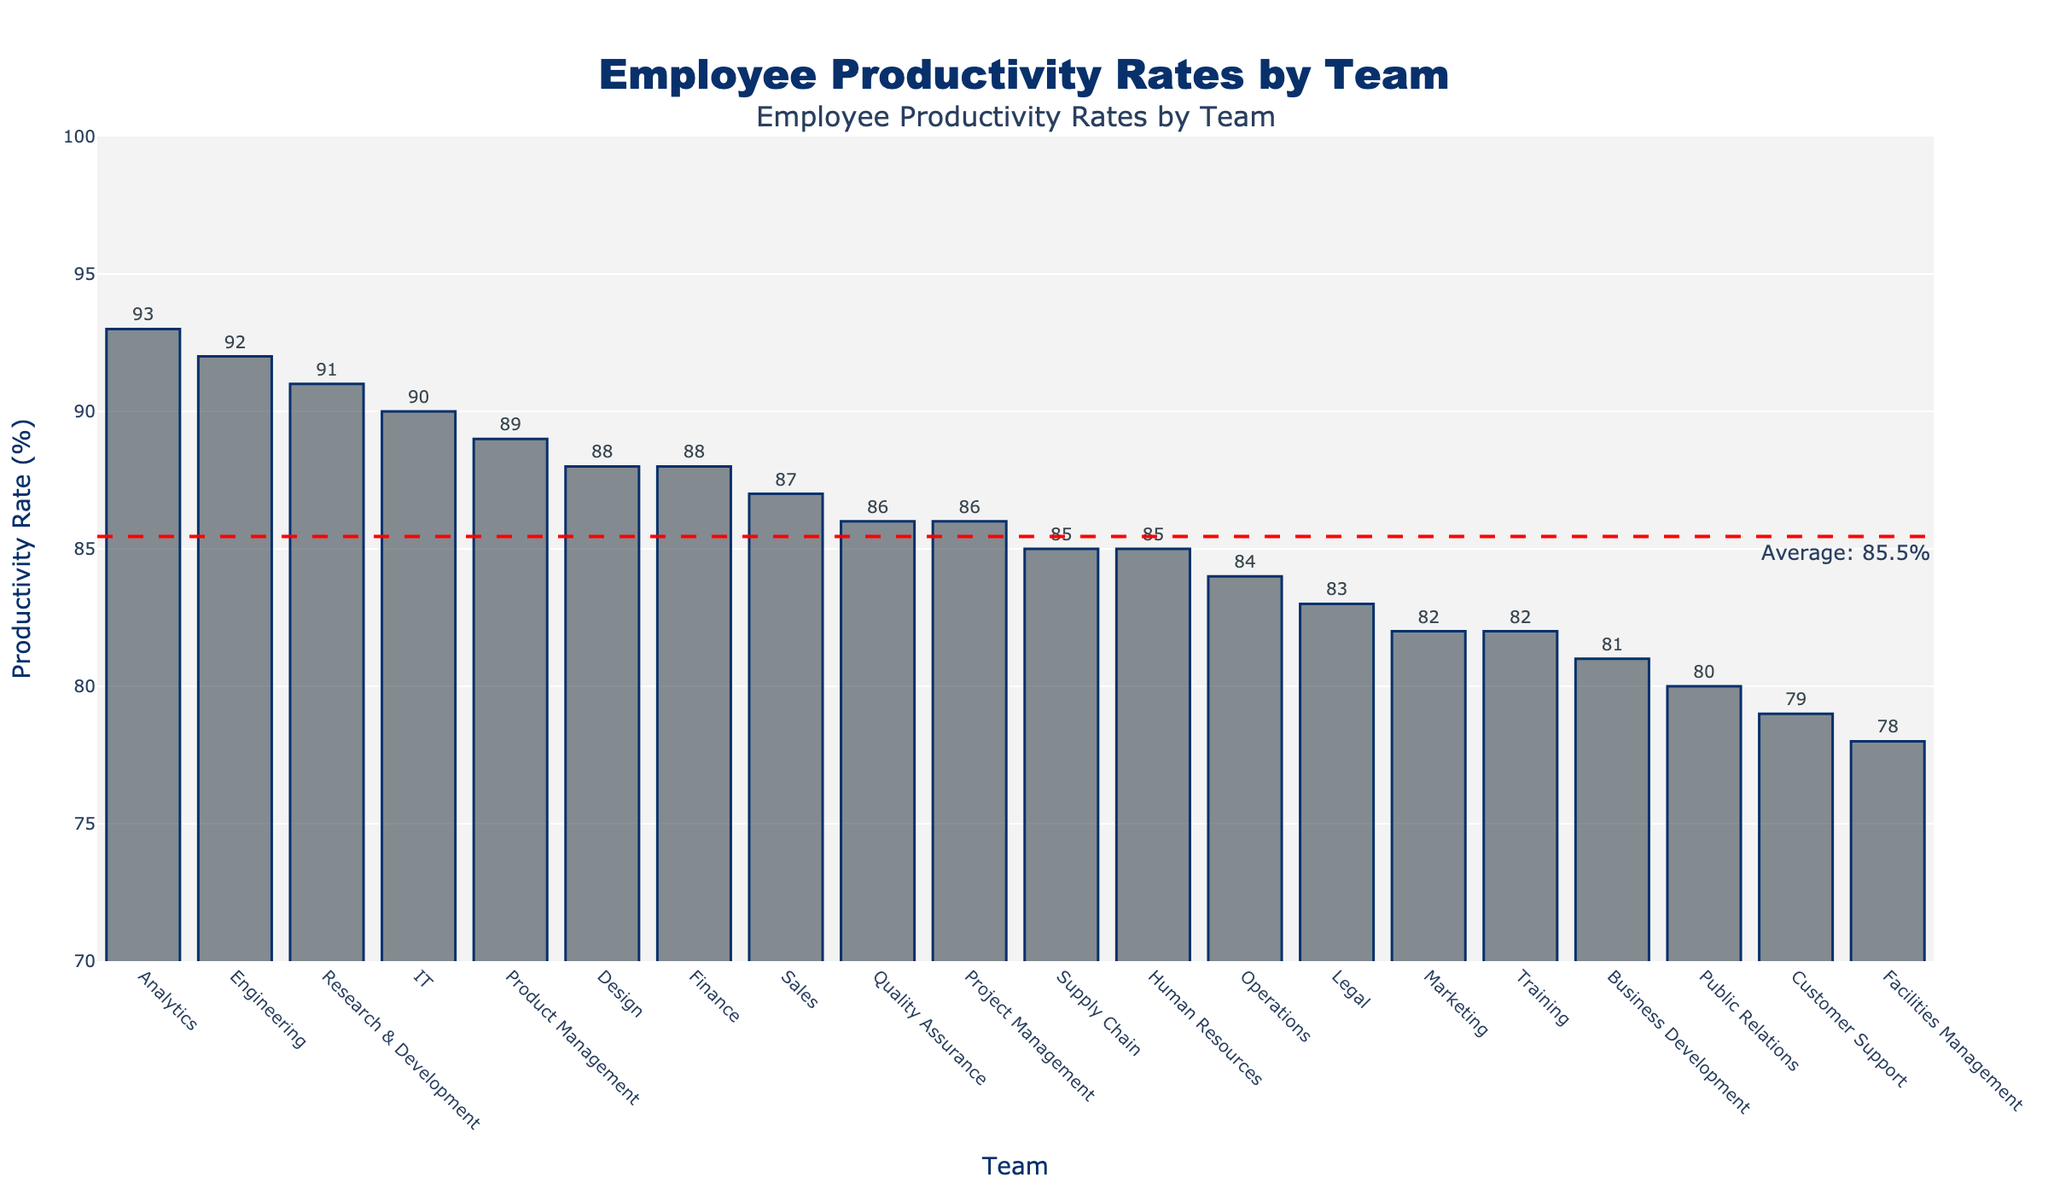Which team has the highest productivity rate? By looking at the length of the bars, the highest bar represents the team with the highest productivity rate. The longest bar corresponds to the Analytics team with a productivity rate of 93%.
Answer: Analytics Which team has the lowest productivity rate? By observing the shortest bar, the team with the lowest productivity rate is identified. The shortest bar corresponds to the Facilities Management team with a productivity rate of 78%.
Answer: Facilities Management What is the average productivity rate across all teams? A horizontal dashed line labeled "Average: ...%" indicates the average productivity rate. The line shows an average of 85.3%.
Answer: 85.3% How does the productivity of the IT team compare to the Finance team? The bar representing IT has a length corresponding to a productivity rate of 90%. The bar for Finance corresponds to a productivity rate of 88%. Thus, IT has a higher productivity rate than Finance.
Answer: IT has a higher productivity rate What is the difference between the highest and the lowest productivity rates? The highest productivity rate is 93% (Analytics), and the lowest is 78% (Facilities Management). The difference is 93% - 78% = 15%.
Answer: 15% Which teams have productivity rates above the average? By comparing the bars above the horizontal dashed line, the teams with rates above the average (85.3%) are Analytics, Engineering, Research & Development, IT, Product Management, Finance, Design, Quality Assurance, Sales, and Human Resources.
Answer: Analytics, Engineering, Research & Development, IT, Product Management, Finance, Design, Quality Assurance, Sales, Human Resources How many teams have a productivity rate below 80%? By counting the number of bars below the 80% mark on the y-axis, the teams identified are Customer Support and Facilities Management.
Answer: 2 Which team has a productivity rate closest to the average? The horizontal dashed line represents the average productivity rate of 85.3%. The teams with productivity rates closest to this value have rates of 85% or 86%. These are Human Resources, Supply Chain, Quality Assurance, and Project Management.
Answer: Human Resources, Supply Chain, Quality Assurance, Project Management What is the median productivity rate, and which team(s) is closest to it? To find the median, the productivity rates must be sorted. Given 20 teams, the median will be the average of the 10th and 11th values. Sorting the rates: 78, 79, 80, 81, 82, 82, 83, 84, 85, 85, 86, 86, 87, 88, 88, 89, 90, 91, 92, 93. The average of the 10th and 11th values (85, 86) is 85.5. The teams closest to this are Quality Assurance and Project Management with 86%.
Answer: Quality Assurance, Project Management Which department shows the most significant deviation from the average productivity rate? To find the most significant deviation, compare the absolute differences from the average rate of 85.3%. The greatest deviation is from Analytics with 93%, showing a deviation of 93% - 85.3% = 7.7%.
Answer: Analytics 